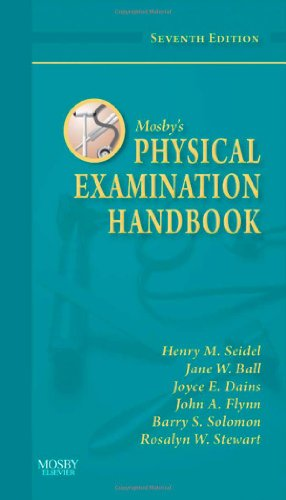What is the title of this book? The book's title is Mosby's Physical Examination Handbook, Seventh Edition, offering a focused guide on physical examination techniques. 